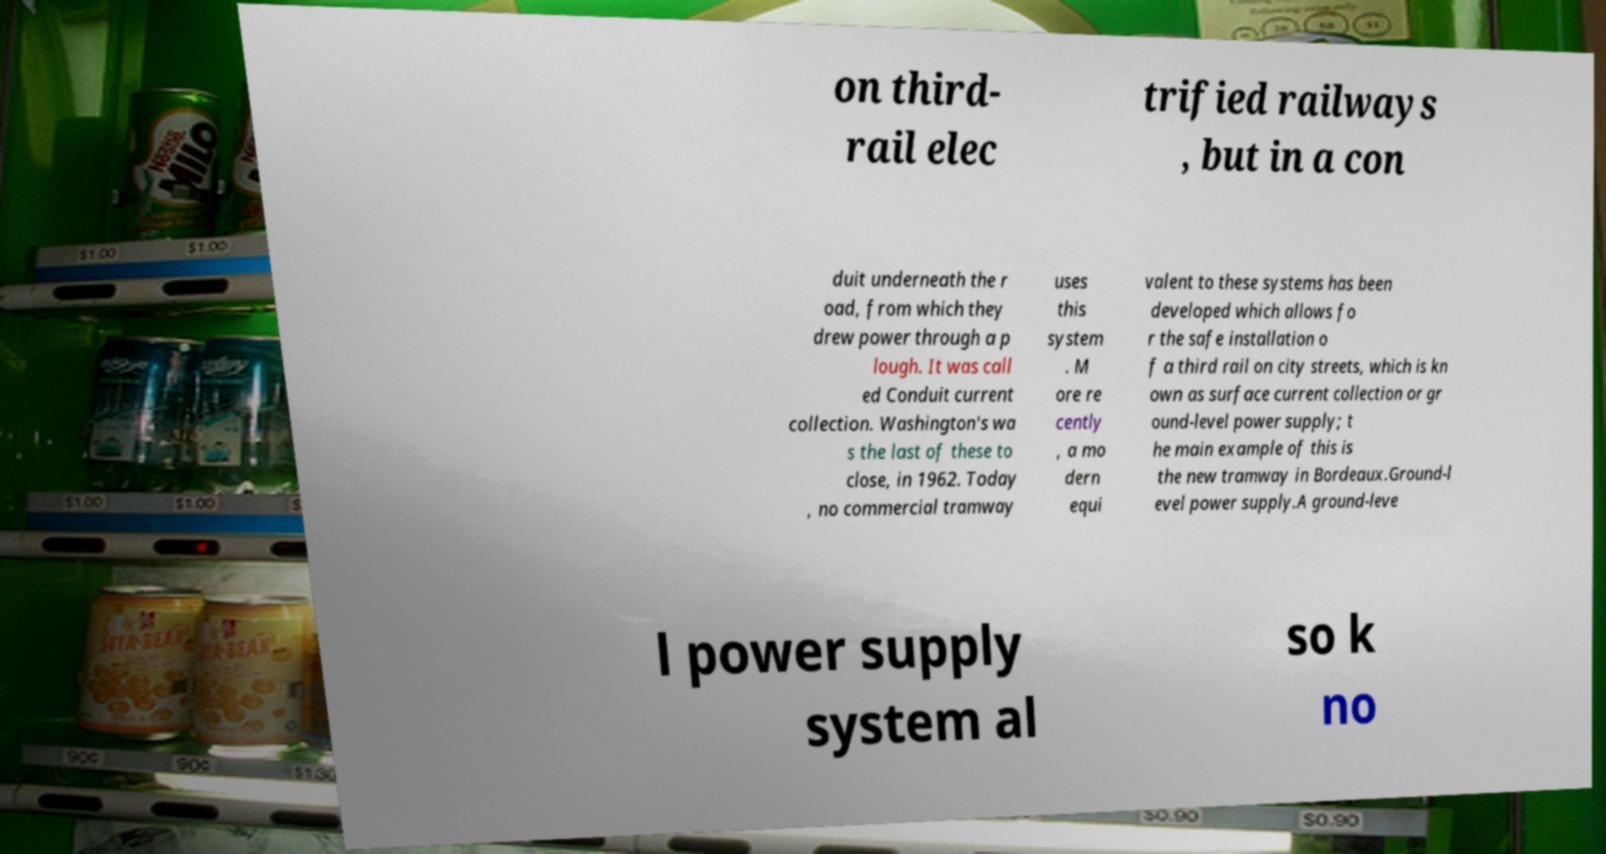Could you assist in decoding the text presented in this image and type it out clearly? on third- rail elec trified railways , but in a con duit underneath the r oad, from which they drew power through a p lough. It was call ed Conduit current collection. Washington's wa s the last of these to close, in 1962. Today , no commercial tramway uses this system . M ore re cently , a mo dern equi valent to these systems has been developed which allows fo r the safe installation o f a third rail on city streets, which is kn own as surface current collection or gr ound-level power supply; t he main example of this is the new tramway in Bordeaux.Ground-l evel power supply.A ground-leve l power supply system al so k no 